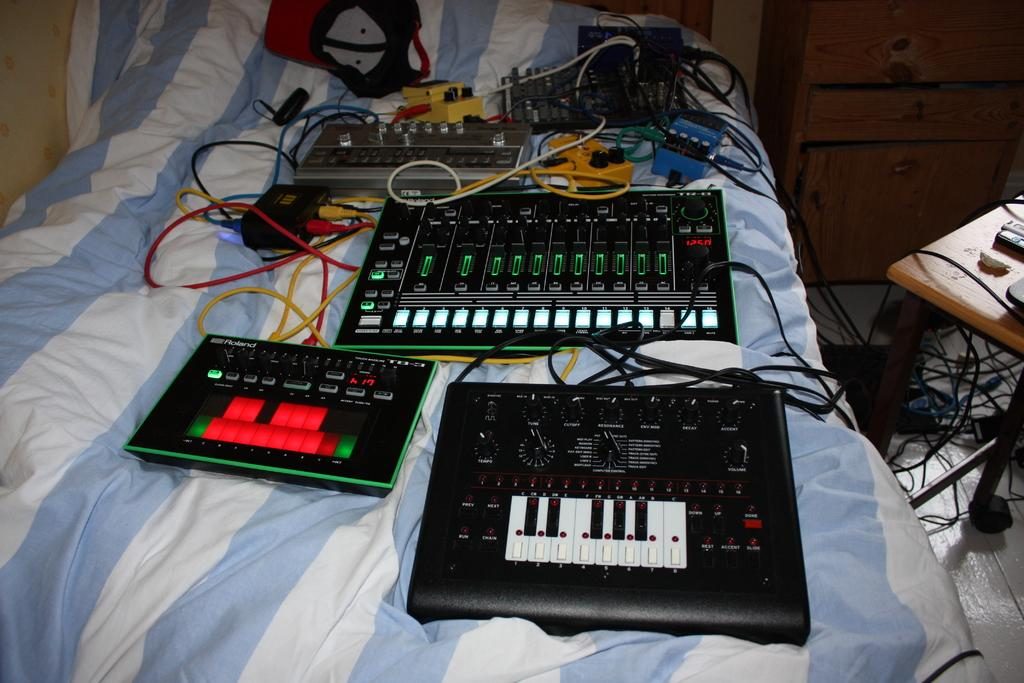What type of objects can be seen in the image? There are electronic gadgets in the image. What piece of furniture is present in the image? There is a bed in the image. What accessory is visible in the image? There is a hat in the image. What connects the electronic gadgets in the image? There are cables in the image. What piece of furniture is used for placing objects in the image? There is a table in the image. What type of storage is available in the image? There are drawers in the image. Can you describe any other objects present in the image? There are other objects in the image, but their specific details are not mentioned in the provided facts. How many houses can be seen in the image? There are no houses present in the image. What type of joke is being told by the hat in the image? There is no joke being told by the hat in the image, as it is an inanimate object. 